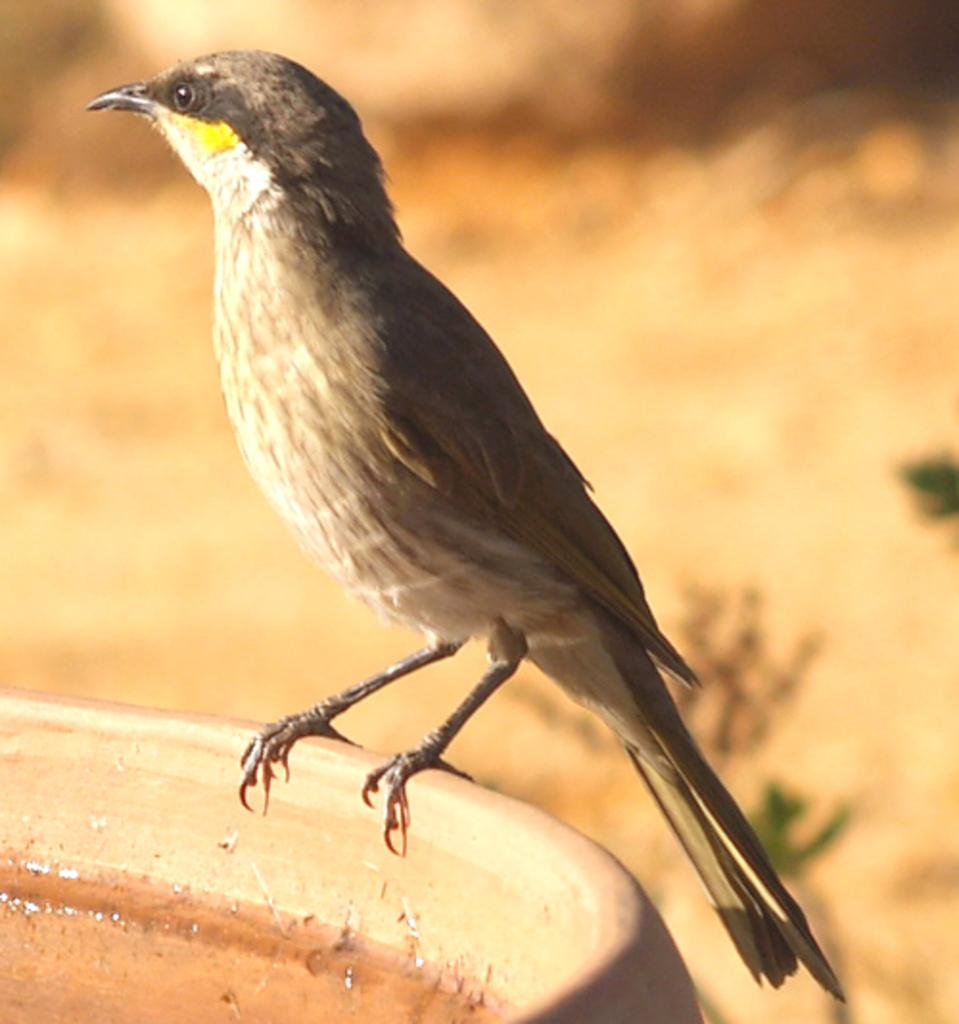What type of animal can be seen in the image? There is a bird in the image. What is the bird doing in the image? The bird is sitting. What can be seen in the foreground of the image? There is water visible in the image. How would you describe the background of the image? The background of the image is blurred. How many brothers does the bird have in the image? There is no information about the bird's brothers in the image. What type of lock is securing the bird in the image? There is no lock present in the image; the bird is sitting freely. 